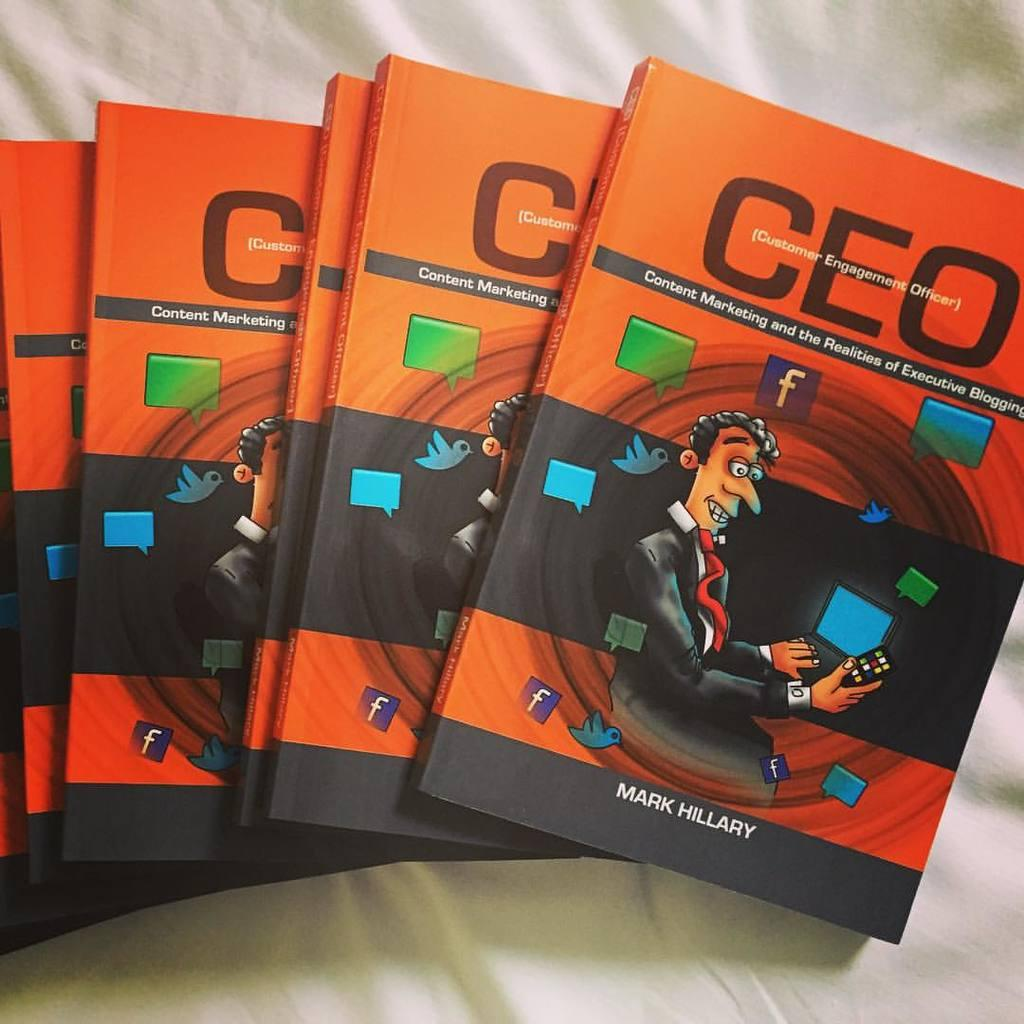<image>
Give a short and clear explanation of the subsequent image. Multiple copy of the book titled "CEO Content Marketing and the Realities of Executive Blogging". 